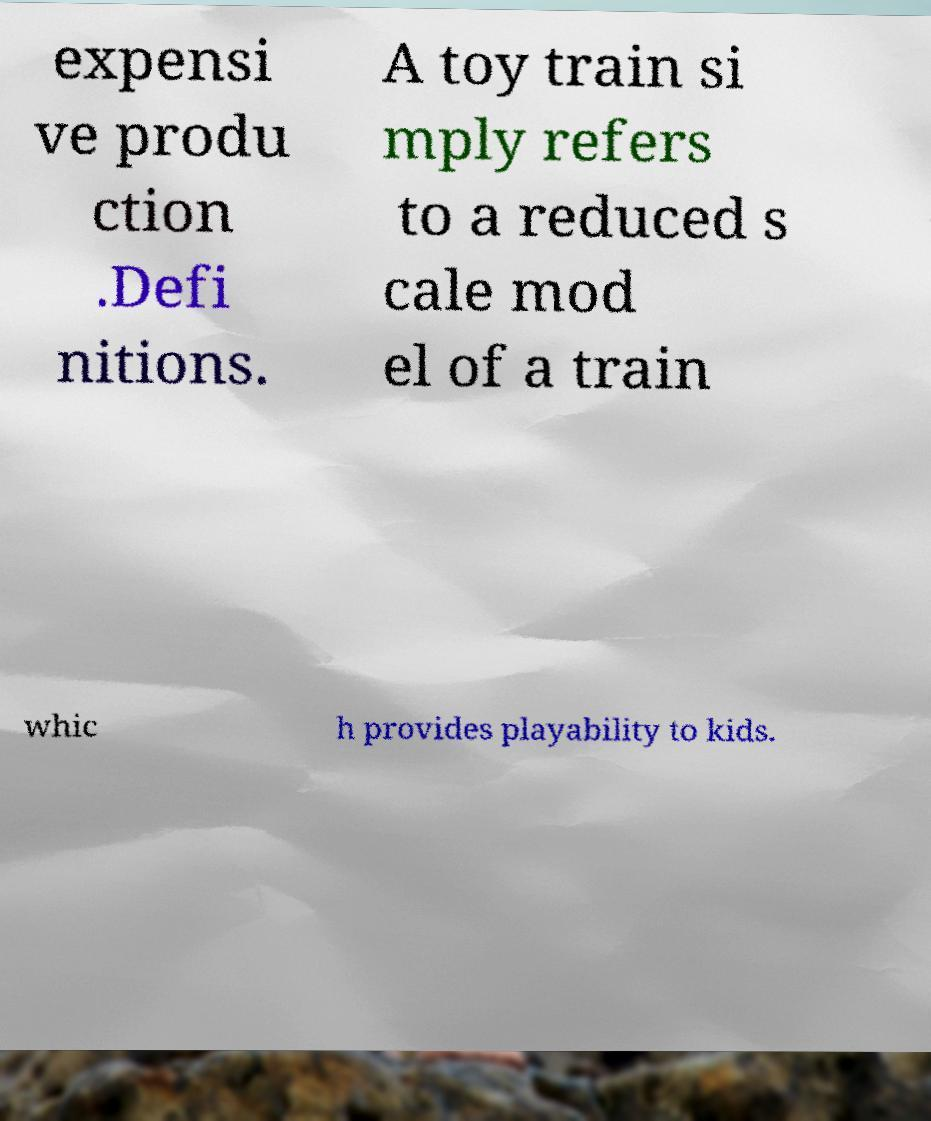There's text embedded in this image that I need extracted. Can you transcribe it verbatim? expensi ve produ ction .Defi nitions. A toy train si mply refers to a reduced s cale mod el of a train whic h provides playability to kids. 